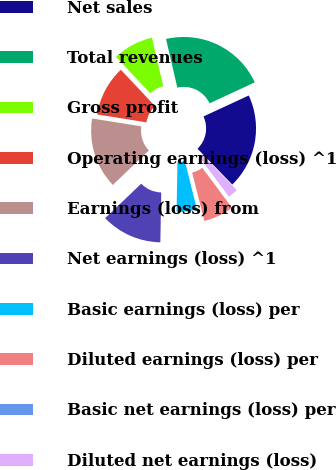Convert chart. <chart><loc_0><loc_0><loc_500><loc_500><pie_chart><fcel>Net sales<fcel>Total revenues<fcel>Gross profit<fcel>Operating earnings (loss) ^1<fcel>Earnings (loss) from<fcel>Net earnings (loss) ^1<fcel>Basic earnings (loss) per<fcel>Diluted earnings (loss) per<fcel>Basic net earnings (loss) per<fcel>Diluted net earnings (loss)<nl><fcel>19.63%<fcel>21.73%<fcel>8.38%<fcel>10.47%<fcel>14.66%<fcel>12.57%<fcel>4.19%<fcel>6.28%<fcel>0.0%<fcel>2.09%<nl></chart> 